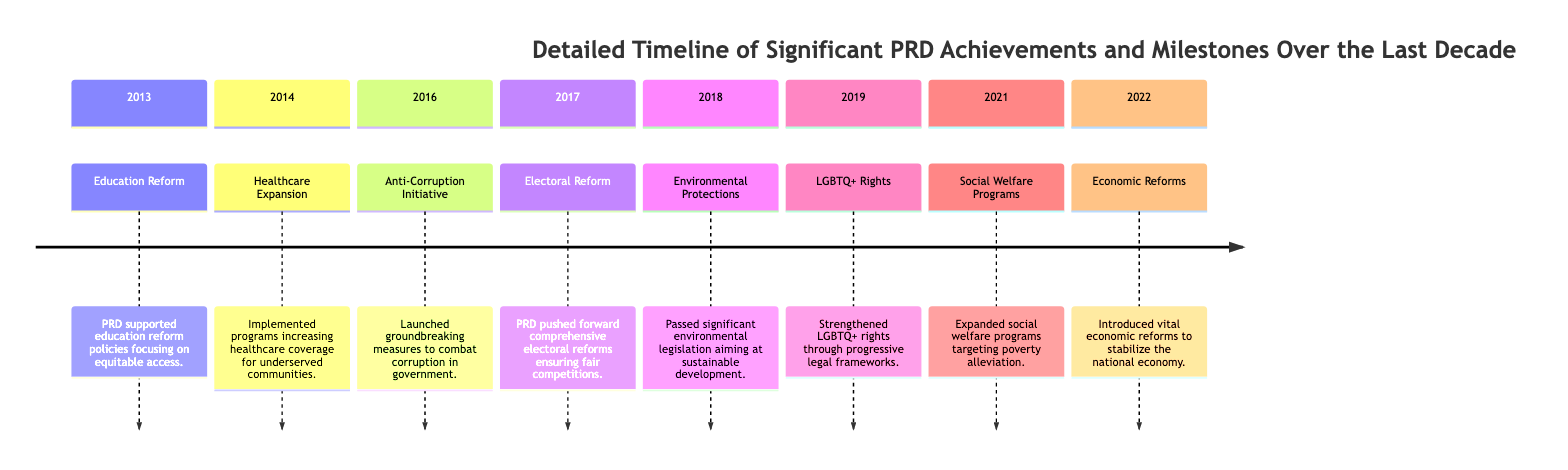What significant achievement occurred in 2013? The diagram indicates that in 2013, the PRD supported education reform policies focusing on equitable access.
Answer: Education Reform What was a major PRD initiative in 2016? According to the timeline, the PRD launched groundbreaking measures to combat corruption in government in 2016.
Answer: Anti-Corruption Initiative How many significant milestones were listed for the year 2022? The diagram shows that there was one significant milestone listed for 2022, which was the introduction of economic reforms.
Answer: 1 Which year did the PRD strengthen LGBTQ+ rights? The timeline highlights that the PRD strengthened LGBTQ+ rights in 2019.
Answer: 2019 Which two achievements occurred after the Environmental Protections milestone? The diagram shows that after Environmental Protections in 2018, the next two achievements were Strengthened LGBTQ+ Rights in 2019 and Expanded Social Welfare Programs in 2021.
Answer: LGBTQ+ Rights, Social Welfare Programs What is the first milestone that relates to social policy? Examining the timeline reveals that the first milestone related to social policy is the Healthcare Expansion initiative in 2014.
Answer: Healthcare Expansion In which year was the Electoral Reform milestone achieved? Based on the diagram, the PRD pushed for Electoral Reform in 2017.
Answer: 2017 What type of reforms were introduced in 2022? The timeline specifies that economic reforms were introduced in 2022.
Answer: Economic Reforms 